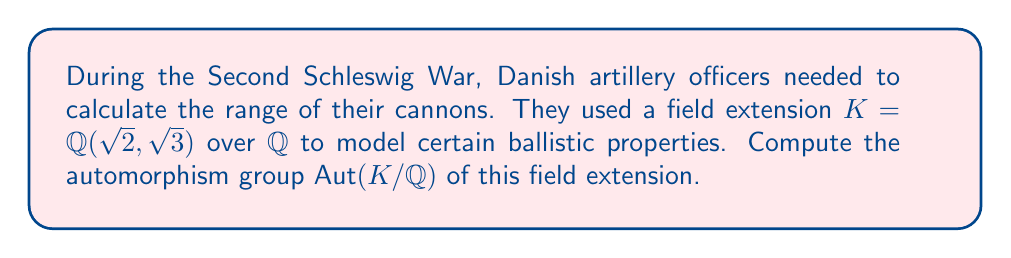Teach me how to tackle this problem. Let's approach this step-by-step:

1) The field $K = \mathbb{Q}(\sqrt{2}, \sqrt{3})$ is a degree 4 extension of $\mathbb{Q}$.

2) Any automorphism in $\text{Aut}(K/\mathbb{Q})$ must fix $\mathbb{Q}$ pointwise and can only permute the roots of the minimal polynomials of $\sqrt{2}$ and $\sqrt{3}$.

3) The possible actions on $\sqrt{2}$ are:
   $\sigma_1(\sqrt{2}) = \sqrt{2}$ or $\sigma_2(\sqrt{2}) = -\sqrt{2}$

4) Similarly for $\sqrt{3}$:
   $\tau_1(\sqrt{3}) = \sqrt{3}$ or $\tau_2(\sqrt{3}) = -\sqrt{3}$

5) This gives us four possible automorphisms:
   $\phi_1: \sqrt{2} \mapsto \sqrt{2}, \sqrt{3} \mapsto \sqrt{3}$ (identity)
   $\phi_2: \sqrt{2} \mapsto -\sqrt{2}, \sqrt{3} \mapsto \sqrt{3}$
   $\phi_3: \sqrt{2} \mapsto \sqrt{2}, \sqrt{3} \mapsto -\sqrt{3}$
   $\phi_4: \sqrt{2} \mapsto -\sqrt{2}, \sqrt{3} \mapsto -\sqrt{3}$

6) These four automorphisms form a group under composition, isomorphic to $C_2 \times C_2$ (Klein four-group).

Therefore, $\text{Aut}(K/\mathbb{Q}) \cong C_2 \times C_2$.
Answer: $C_2 \times C_2$ 